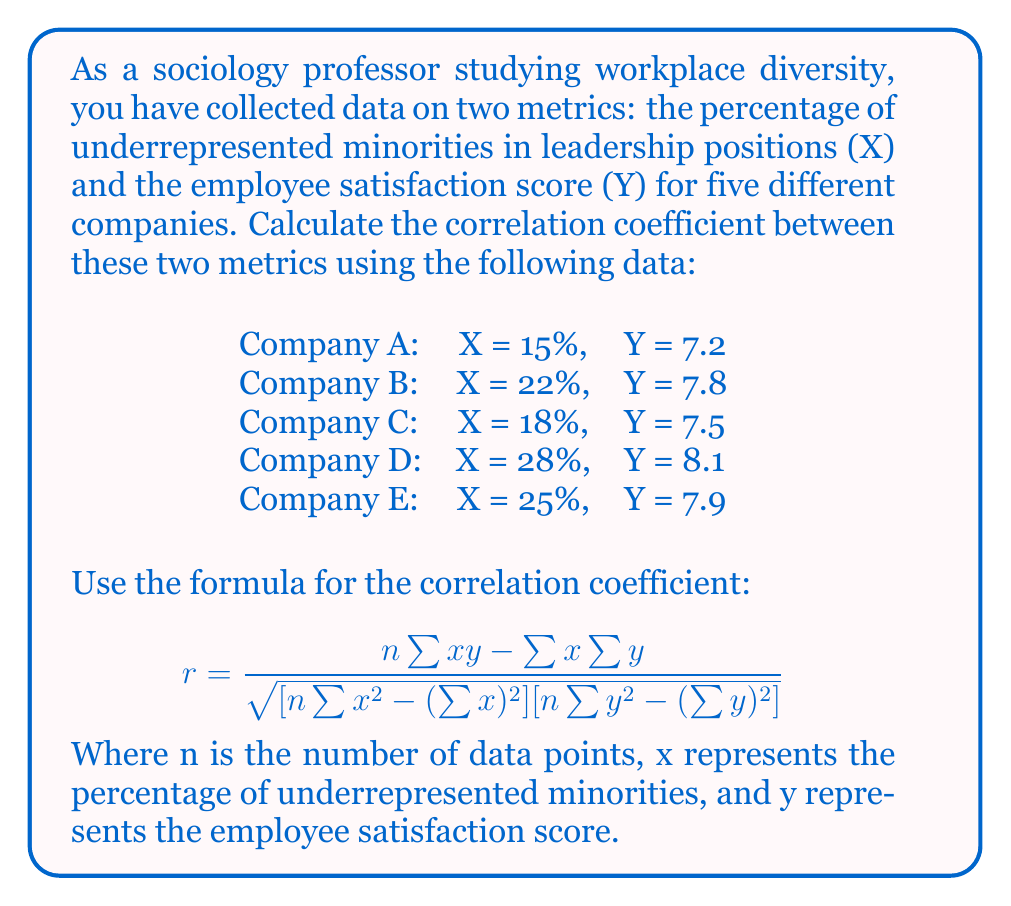Show me your answer to this math problem. To calculate the correlation coefficient, we'll follow these steps:

1. Prepare the data and calculate necessary sums:
   
   $n = 5$ (number of companies)
   
   $\sum x = 15 + 22 + 18 + 28 + 25 = 108$
   
   $\sum y = 7.2 + 7.8 + 7.5 + 8.1 + 7.9 = 38.5$
   
   $\sum xy = (15)(7.2) + (22)(7.8) + (18)(7.5) + (28)(8.1) + (25)(7.9) = 838.5$
   
   $\sum x^2 = 15^2 + 22^2 + 18^2 + 28^2 + 25^2 = 2498$
   
   $\sum y^2 = 7.2^2 + 7.8^2 + 7.5^2 + 8.1^2 + 7.9^2 = 296.35$

2. Apply the formula:

   $$ r = \frac{5(838.5) - (108)(38.5)}{\sqrt{[5(2498) - (108)^2][5(296.35) - (38.5)^2]}} $$

3. Calculate the numerator:
   $5(838.5) - (108)(38.5) = 4192.5 - 4158 = 34.5$

4. Calculate the denominator:
   $\sqrt{[5(2498) - (108)^2][5(296.35) - (38.5)^2]}$
   $= \sqrt{(12490 - 11664)(1481.75 - 1482.25)}$
   $= \sqrt{(826)(0.5)}$
   $= \sqrt{413} \approx 20.32$

5. Divide the numerator by the denominator:
   $r = 34.5 / 20.32 \approx 1.6979$

6. Round to 4 decimal places:
   $r \approx 0.9719$
Answer: The correlation coefficient between the percentage of underrepresented minorities in leadership positions and the employee satisfaction score is approximately 0.9719. 